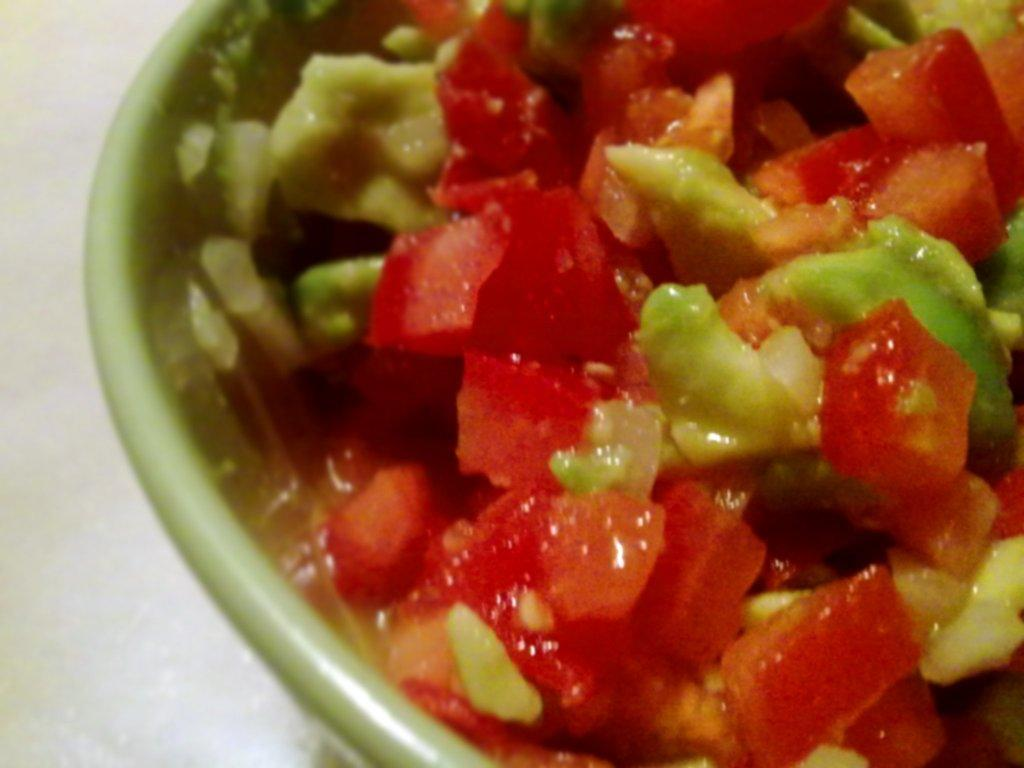What is in the bowl that is visible in the image? The bowl contains food. What type of food is in the bowl? The bowl contains vegetable slices. Where is the bowl located in the image? The bowl is kept on the floor. How many apples are being stitched together in the image? There are no apples or stitching present in the image. What type of mask is being worn by the person in the image? There is no person or mask present in the image. 